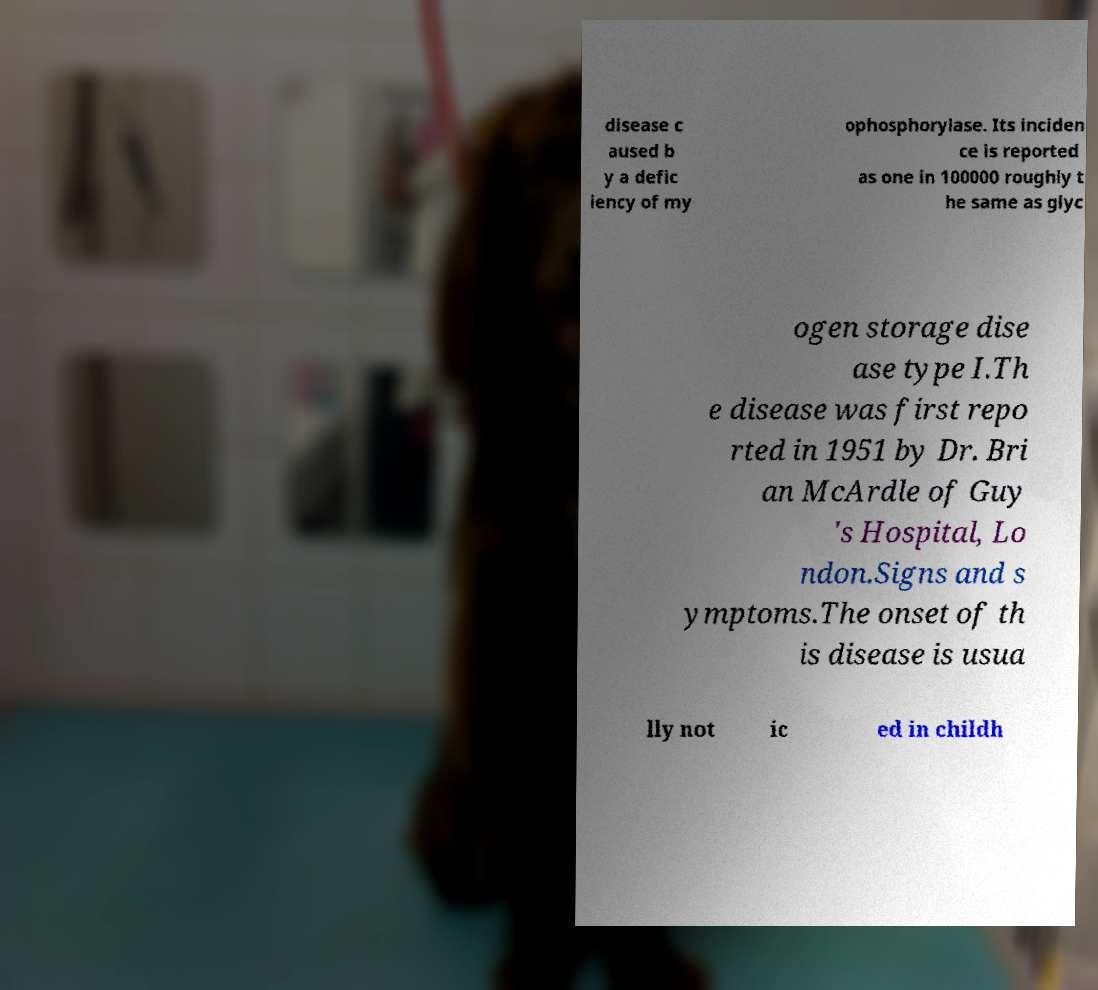There's text embedded in this image that I need extracted. Can you transcribe it verbatim? disease c aused b y a defic iency of my ophosphorylase. Its inciden ce is reported as one in 100000 roughly t he same as glyc ogen storage dise ase type I.Th e disease was first repo rted in 1951 by Dr. Bri an McArdle of Guy 's Hospital, Lo ndon.Signs and s ymptoms.The onset of th is disease is usua lly not ic ed in childh 